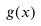<formula> <loc_0><loc_0><loc_500><loc_500>g ( x )</formula> 